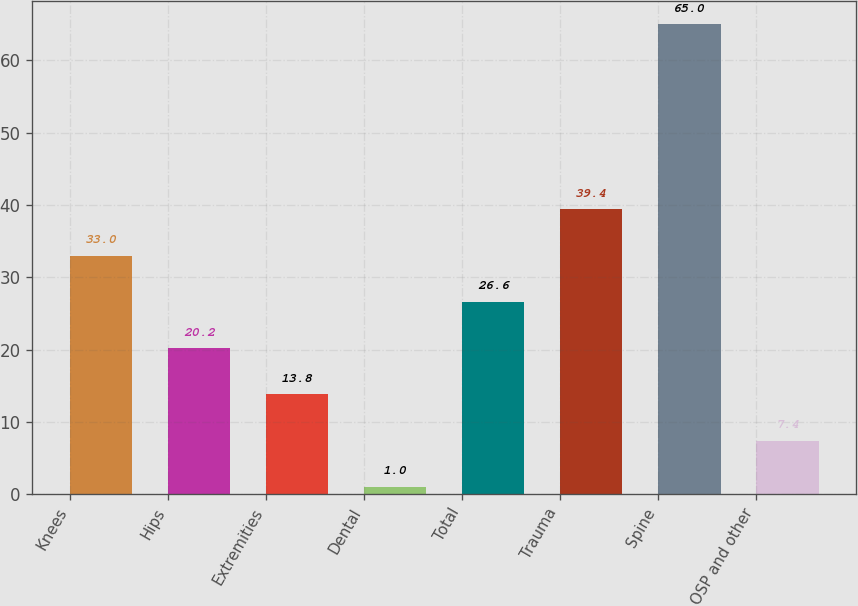<chart> <loc_0><loc_0><loc_500><loc_500><bar_chart><fcel>Knees<fcel>Hips<fcel>Extremities<fcel>Dental<fcel>Total<fcel>Trauma<fcel>Spine<fcel>OSP and other<nl><fcel>33<fcel>20.2<fcel>13.8<fcel>1<fcel>26.6<fcel>39.4<fcel>65<fcel>7.4<nl></chart> 